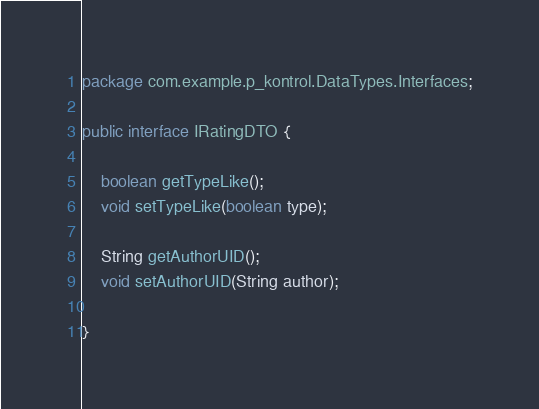<code> <loc_0><loc_0><loc_500><loc_500><_Java_>package com.example.p_kontrol.DataTypes.Interfaces;

public interface IRatingDTO {

    boolean getTypeLike();
    void setTypeLike(boolean type);

    String getAuthorUID();
    void setAuthorUID(String author);

}
</code> 